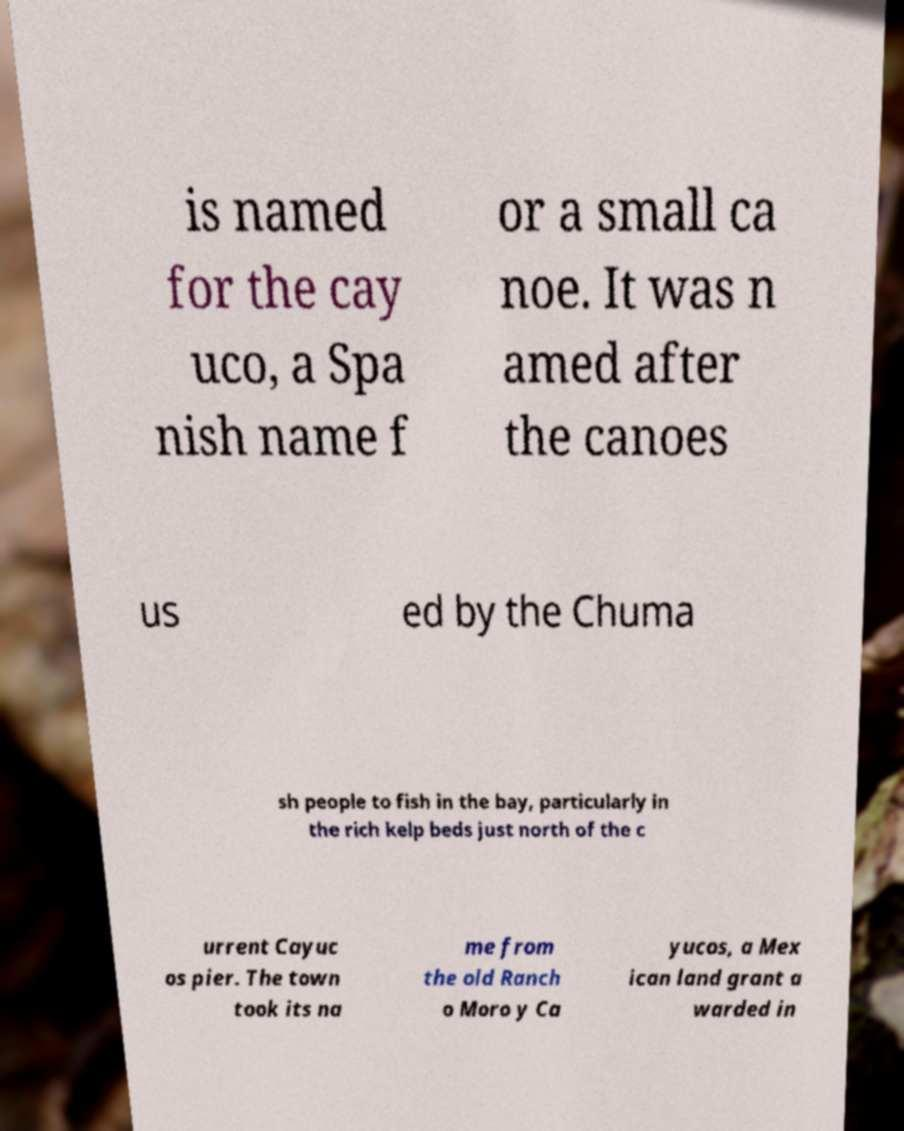Could you extract and type out the text from this image? is named for the cay uco, a Spa nish name f or a small ca noe. It was n amed after the canoes us ed by the Chuma sh people to fish in the bay, particularly in the rich kelp beds just north of the c urrent Cayuc os pier. The town took its na me from the old Ranch o Moro y Ca yucos, a Mex ican land grant a warded in 